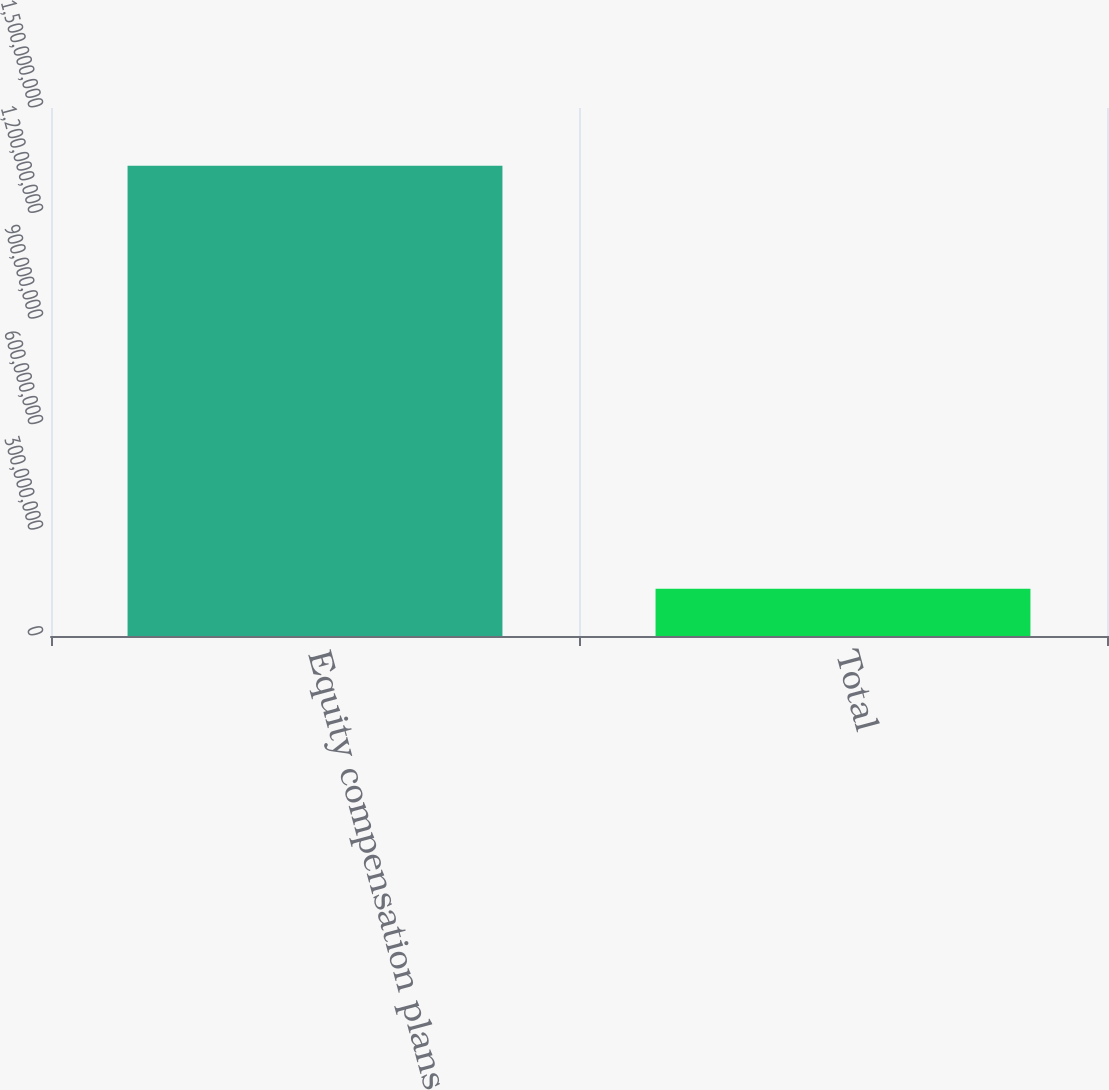<chart> <loc_0><loc_0><loc_500><loc_500><bar_chart><fcel>Equity compensation plans<fcel>Total<nl><fcel>1.33608e+09<fcel>1.34377e+08<nl></chart> 